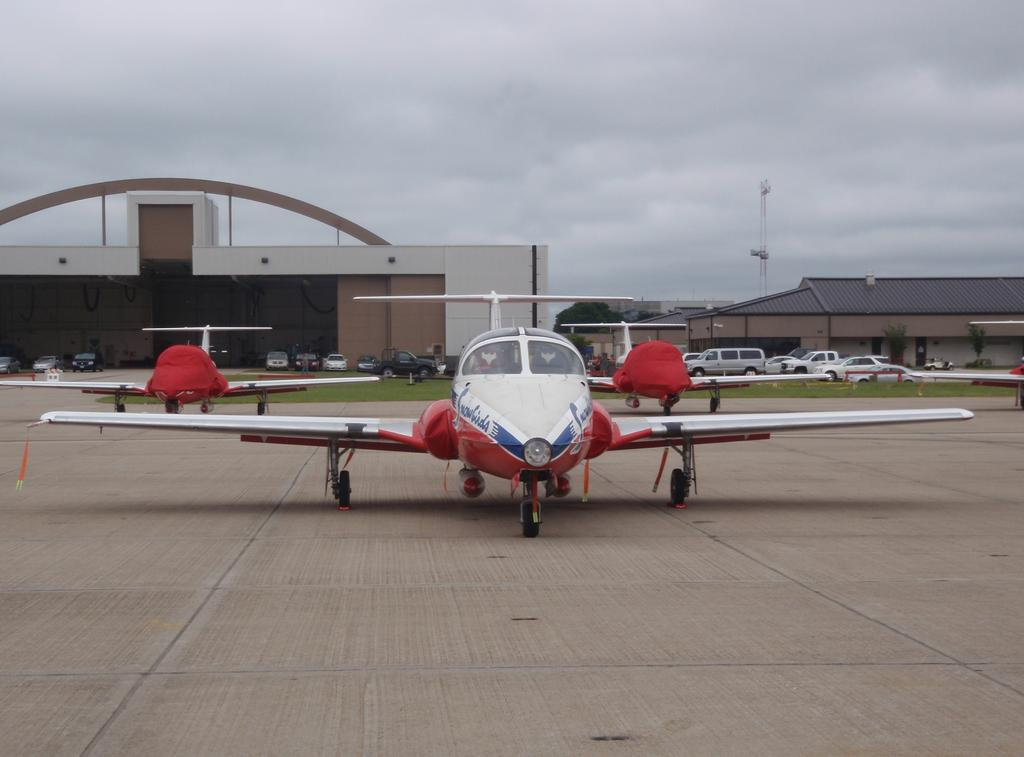What is located in the foreground of the image? There are aircraft in the foreground of the image. What else can be seen in the image besides the aircraft? There are vehicles, grassland, sheds, trees, and a tower visible in the image. What type of terrain is present in the image? The image features grassland. What is visible in the background of the image? The sky is visible in the background of the image. Where is the van parked in the image? There is no van present in the image. What type of yard is visible in the image? There is no yard visible in the image. 